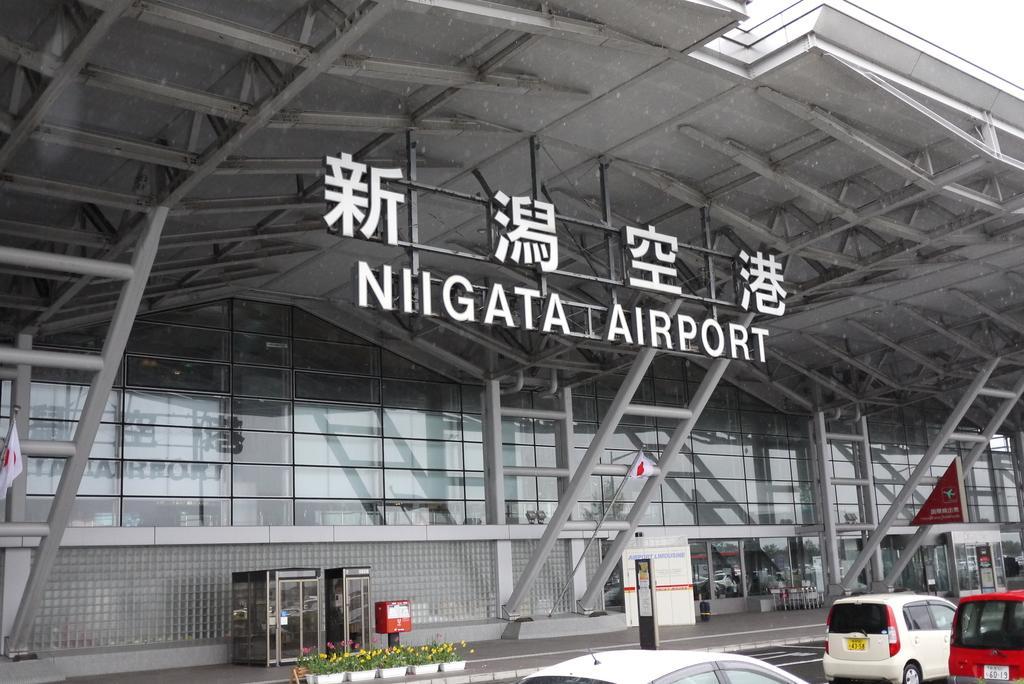Could you give a brief overview of what you see in this image? In this image I can see few vehicles on the road. Background I can see a glass building and I can see few poles in gray color 